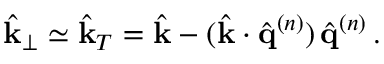<formula> <loc_0><loc_0><loc_500><loc_500>\hat { k } _ { \perp } \simeq \hat { k } _ { T } = \hat { k } - ( \hat { k } \cdot \hat { q } ^ { ( n ) } ) \, \hat { q } ^ { ( n ) } \, .</formula> 